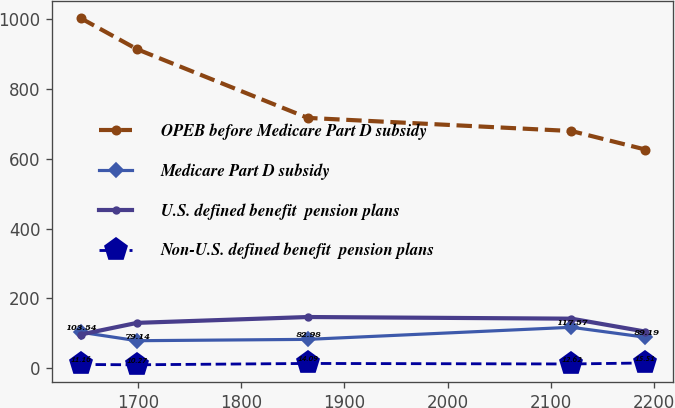Convert chart. <chart><loc_0><loc_0><loc_500><loc_500><line_chart><ecel><fcel>OPEB before Medicare Part D subsidy<fcel>Medicare Part D subsidy<fcel>U.S. defined benefit  pension plans<fcel>Non-U.S. defined benefit  pension plans<nl><fcel>1643.94<fcel>1002.01<fcel>103.54<fcel>96.75<fcel>11.16<nl><fcel>1698.72<fcel>912.98<fcel>79.14<fcel>130.17<fcel>10.27<nl><fcel>1864.35<fcel>716.49<fcel>82.98<fcel>146.91<fcel>14.09<nl><fcel>2120.2<fcel>678.89<fcel>117.57<fcel>142.17<fcel>12.62<nl><fcel>2191.73<fcel>626.06<fcel>89.19<fcel>105.25<fcel>15.51<nl></chart> 